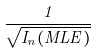Convert formula to latex. <formula><loc_0><loc_0><loc_500><loc_500>\frac { 1 } { \sqrt { I _ { n } ( M L E ) } }</formula> 